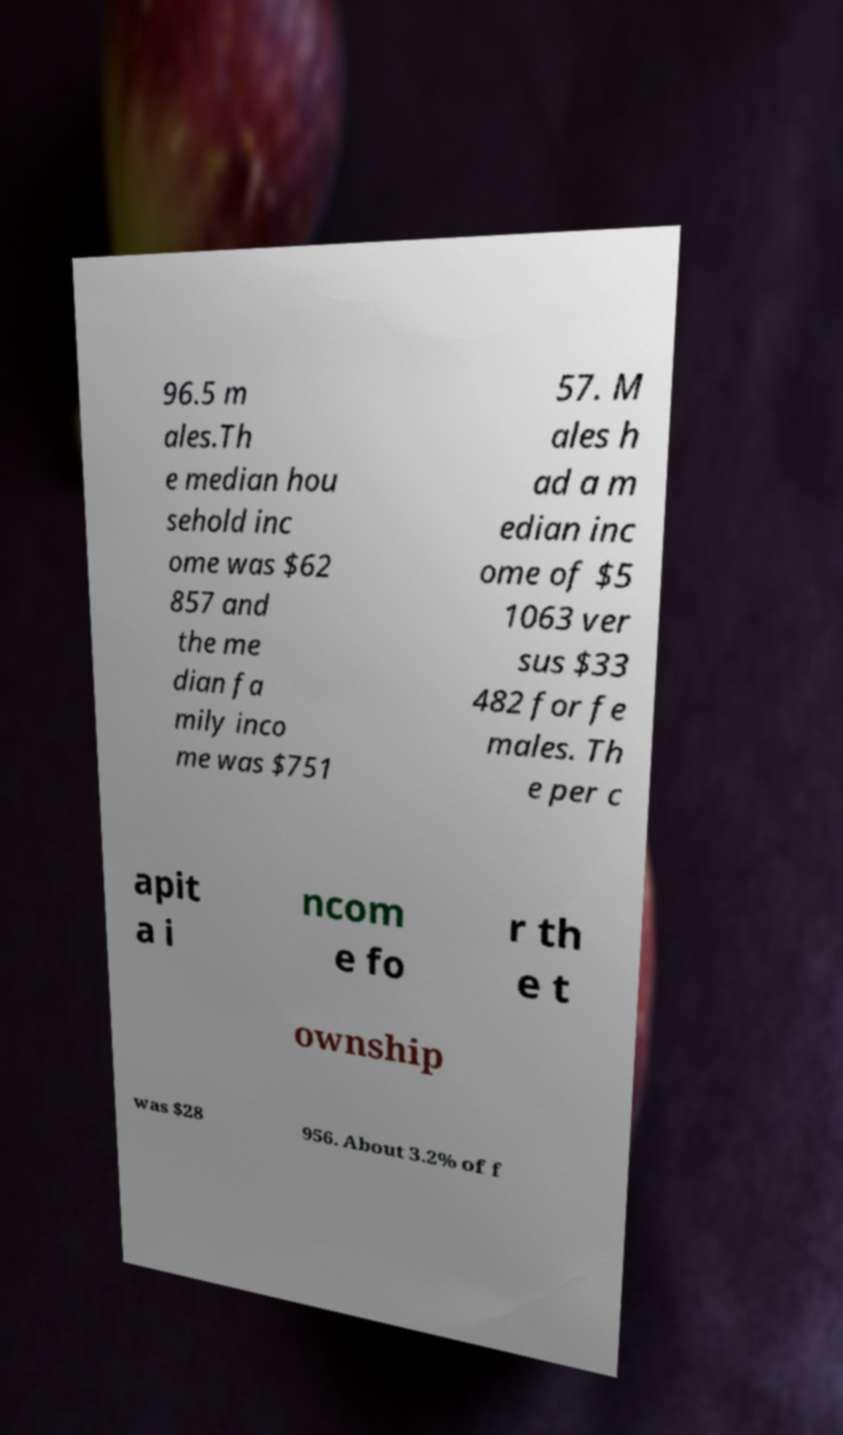I need the written content from this picture converted into text. Can you do that? 96.5 m ales.Th e median hou sehold inc ome was $62 857 and the me dian fa mily inco me was $751 57. M ales h ad a m edian inc ome of $5 1063 ver sus $33 482 for fe males. Th e per c apit a i ncom e fo r th e t ownship was $28 956. About 3.2% of f 